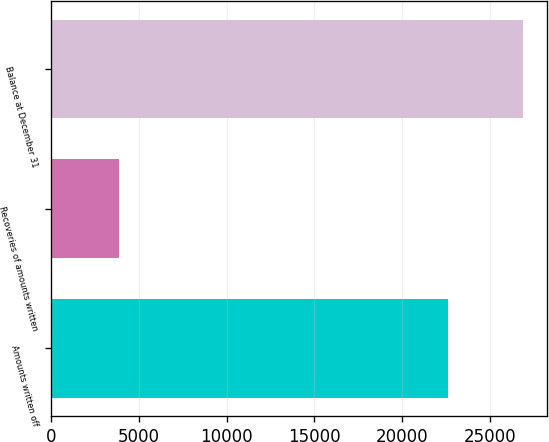<chart> <loc_0><loc_0><loc_500><loc_500><bar_chart><fcel>Amounts written off<fcel>Recoveries of amounts written<fcel>Balance at December 31<nl><fcel>22607<fcel>3875<fcel>26874<nl></chart> 